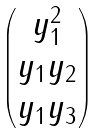<formula> <loc_0><loc_0><loc_500><loc_500>\begin{pmatrix} y _ { 1 } ^ { 2 } \\ y _ { 1 } y _ { 2 } \\ y _ { 1 } y _ { 3 } \end{pmatrix}</formula> 